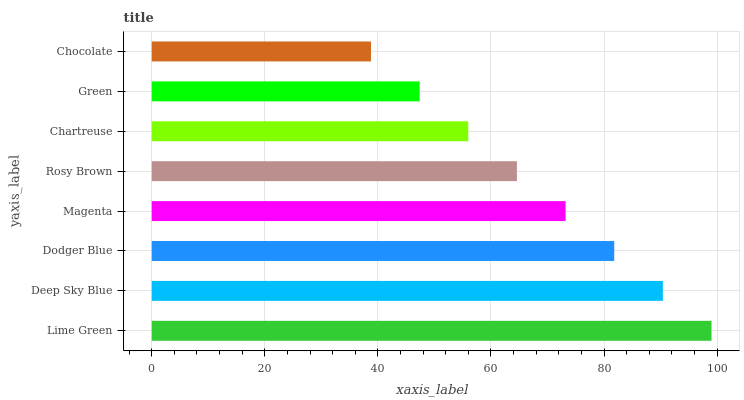Is Chocolate the minimum?
Answer yes or no. Yes. Is Lime Green the maximum?
Answer yes or no. Yes. Is Deep Sky Blue the minimum?
Answer yes or no. No. Is Deep Sky Blue the maximum?
Answer yes or no. No. Is Lime Green greater than Deep Sky Blue?
Answer yes or no. Yes. Is Deep Sky Blue less than Lime Green?
Answer yes or no. Yes. Is Deep Sky Blue greater than Lime Green?
Answer yes or no. No. Is Lime Green less than Deep Sky Blue?
Answer yes or no. No. Is Magenta the high median?
Answer yes or no. Yes. Is Rosy Brown the low median?
Answer yes or no. Yes. Is Lime Green the high median?
Answer yes or no. No. Is Green the low median?
Answer yes or no. No. 